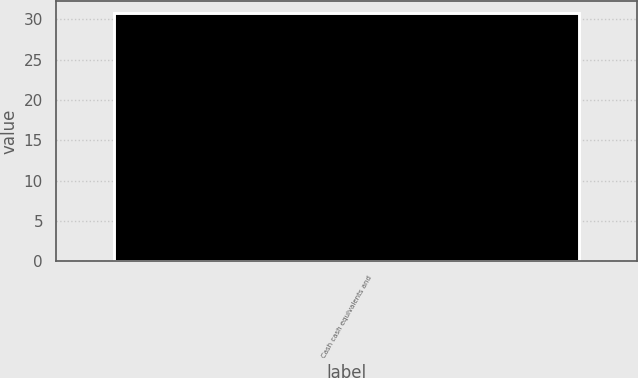<chart> <loc_0><loc_0><loc_500><loc_500><bar_chart><fcel>Cash cash equivalents and<nl><fcel>30.8<nl></chart> 